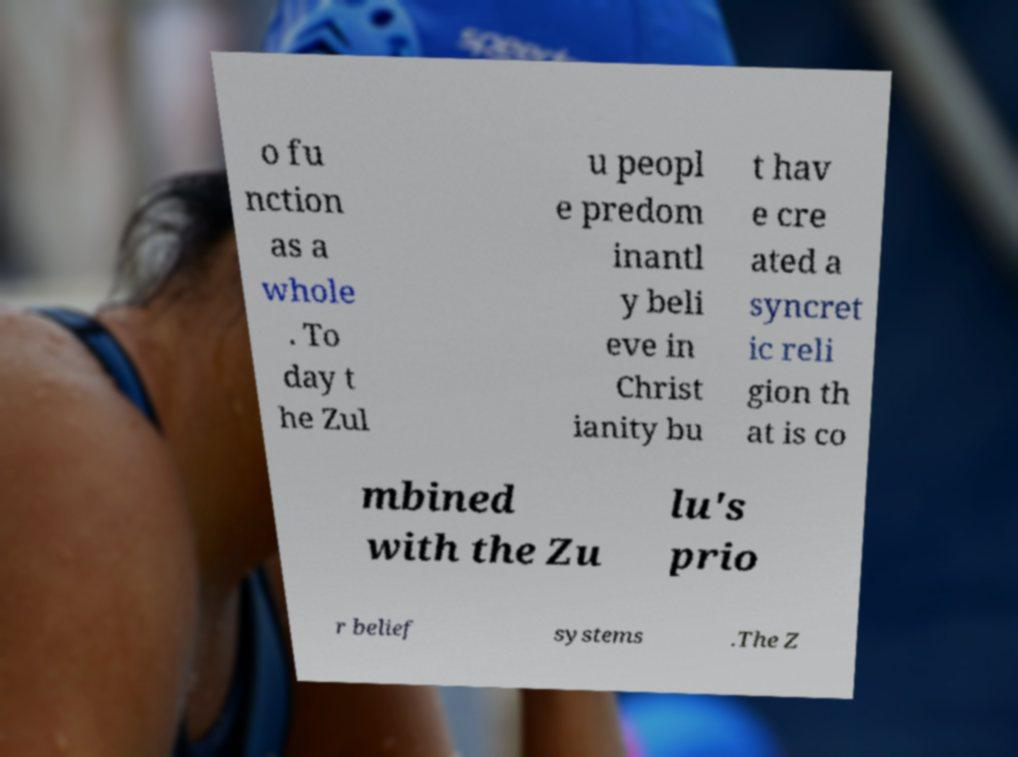I need the written content from this picture converted into text. Can you do that? o fu nction as a whole . To day t he Zul u peopl e predom inantl y beli eve in Christ ianity bu t hav e cre ated a syncret ic reli gion th at is co mbined with the Zu lu's prio r belief systems .The Z 